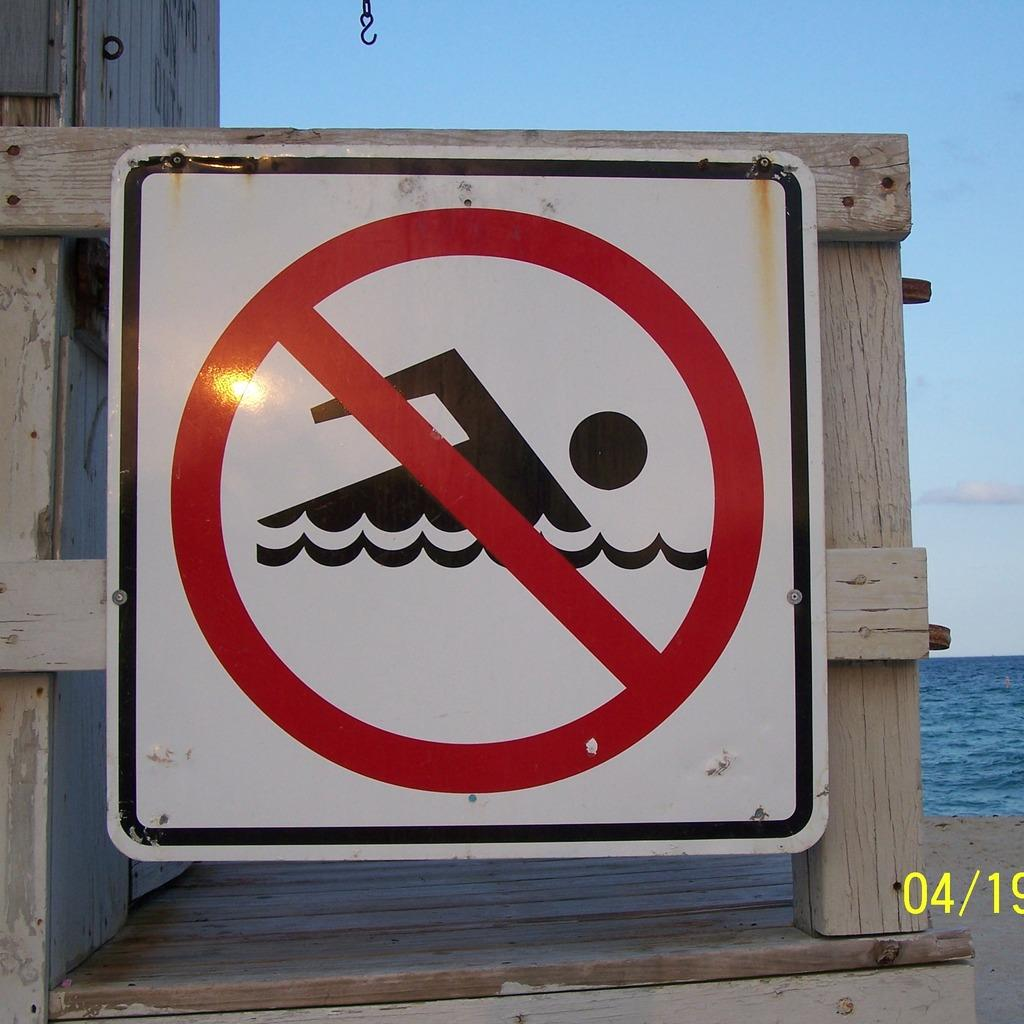What is the main subject of the image? The main subject of the image is a swimming prohibition board. How is the board attached to its support? The board is attached to wooden sticks. What can be seen in the background of the image? There is a sea visible behind the board. How many cats are sitting on top of the swimming prohibition board in the image? There are no cats present in the image, and the board does not have any visible cats sitting on top of it. 